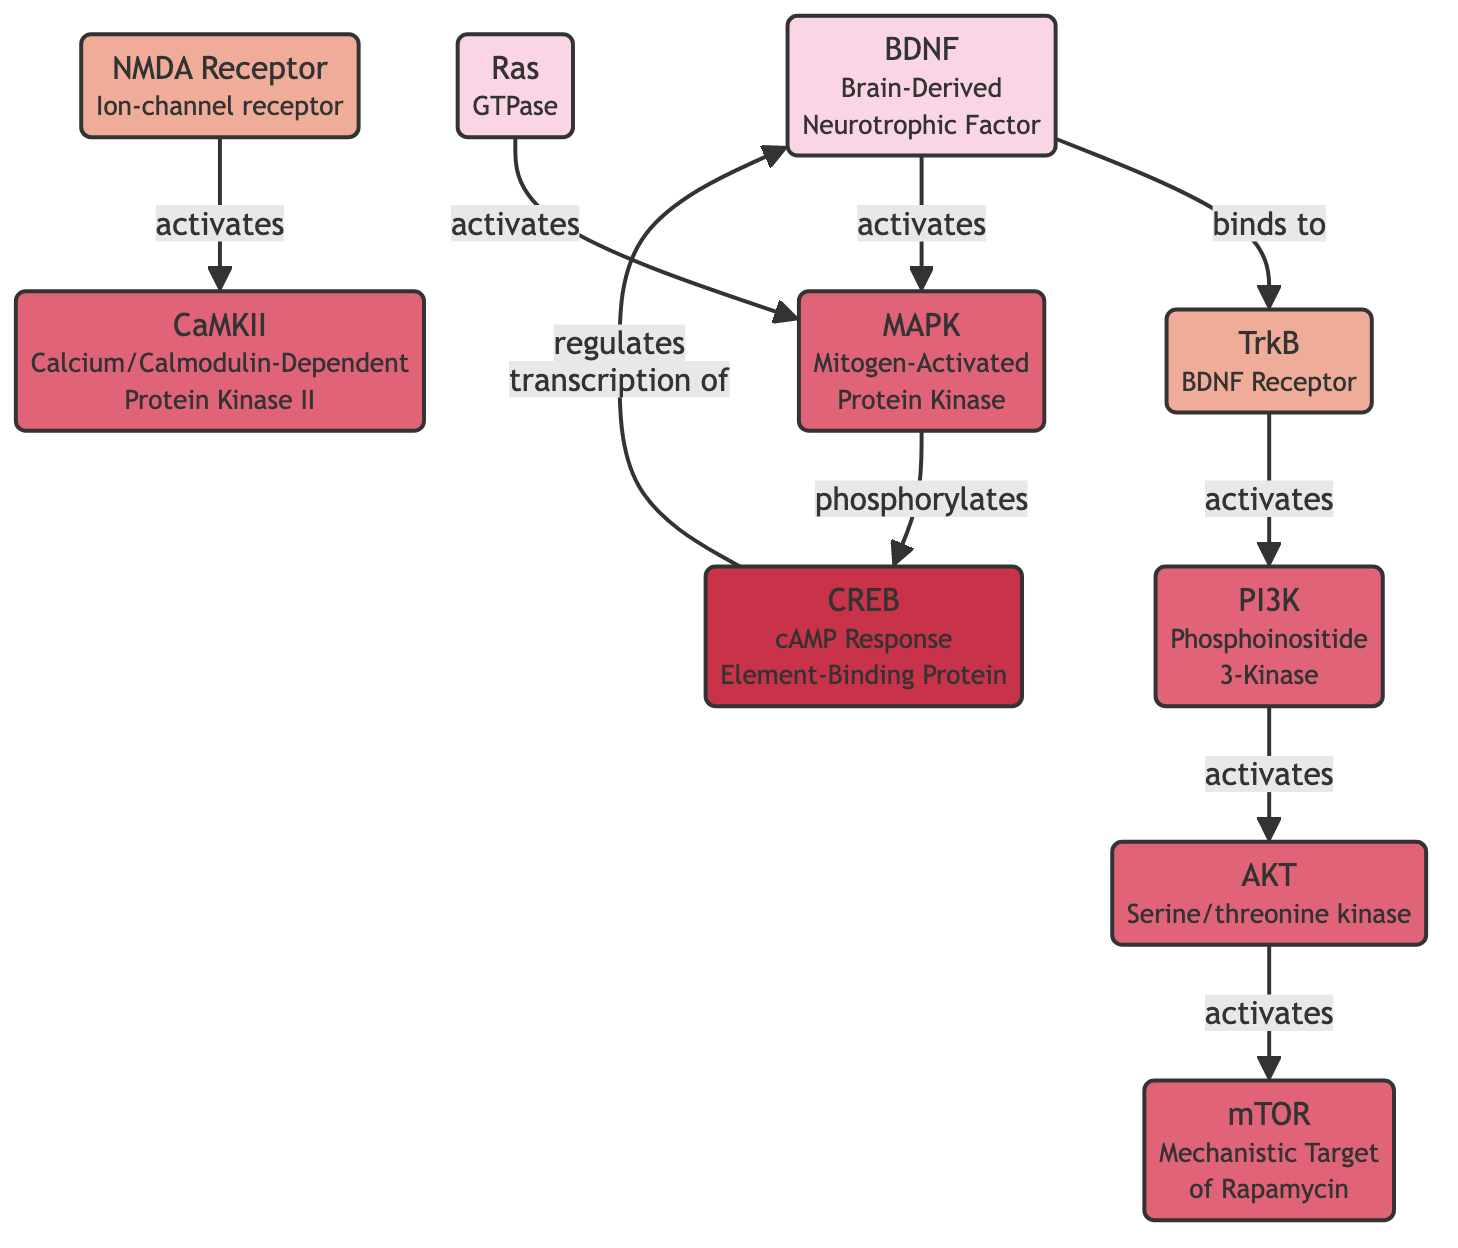What gene is activated by TrkB? TrkB activates PI3K as shown by the directed arrow from TrkB to PI3K in the diagram, indicating a direct activation. Thus, the gene activated by TrkB is BDNF.
Answer: BDNF How many kinases are present in the diagram? By counting the nodes categorized as kinases in the diagram, we find that there are five nodes: AKT, MAPK, PI3K, CaMKII, and mTOR. Therefore, the count is five.
Answer: 5 What receptor does BDNF bind to? According to the diagram, BDNF has a directed edge pointing to the node labeled TrkB, indicating that it binds to TrkB.
Answer: TrkB What is the role of AKT in the signaling pathway? The diagram shows that AKT activates mTOR, so its role here is to activate mTOR after being activated by PI3K.
Answer: Activates mTOR Which protein phosphorylates CREB? The diagram indicates that MAPK has a directed edge towards CREB, labeled as 'phosphorylates,' which specifies that MAPK is responsible for phosphorylating CREB.
Answer: MAPK What is the function of NMDA in this network? NMDA is connected to CaMKII with an activation relationship, which means it activates CaMKII, playing a critical role in this signaling pathway.
Answer: Activates CaMKII How many total nodes are in the diagram? By tallying all the nodes displayed in the diagram, including genes, receptors, kinases, and transcription factors, we find a total of 9 nodes: BDNF, AKT, CREB, MAPK, PI3K, CaMKII, Ras, NMDA, and TrkB.
Answer: 9 Which gene regulates the transcription of BDNF? The directed edge from CREB to BDNF labeled 'regulates transcription of' indicates that CREB is responsible for regulating the transcription of BDNF.
Answer: CREB 